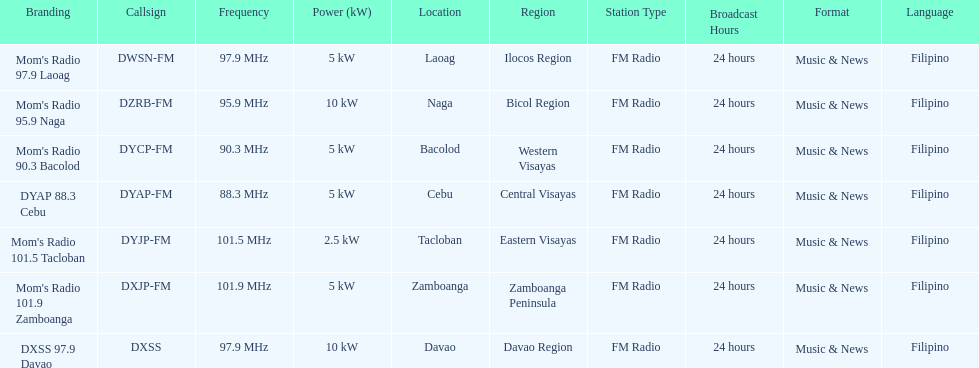What is the last location on this chart? Davao. 